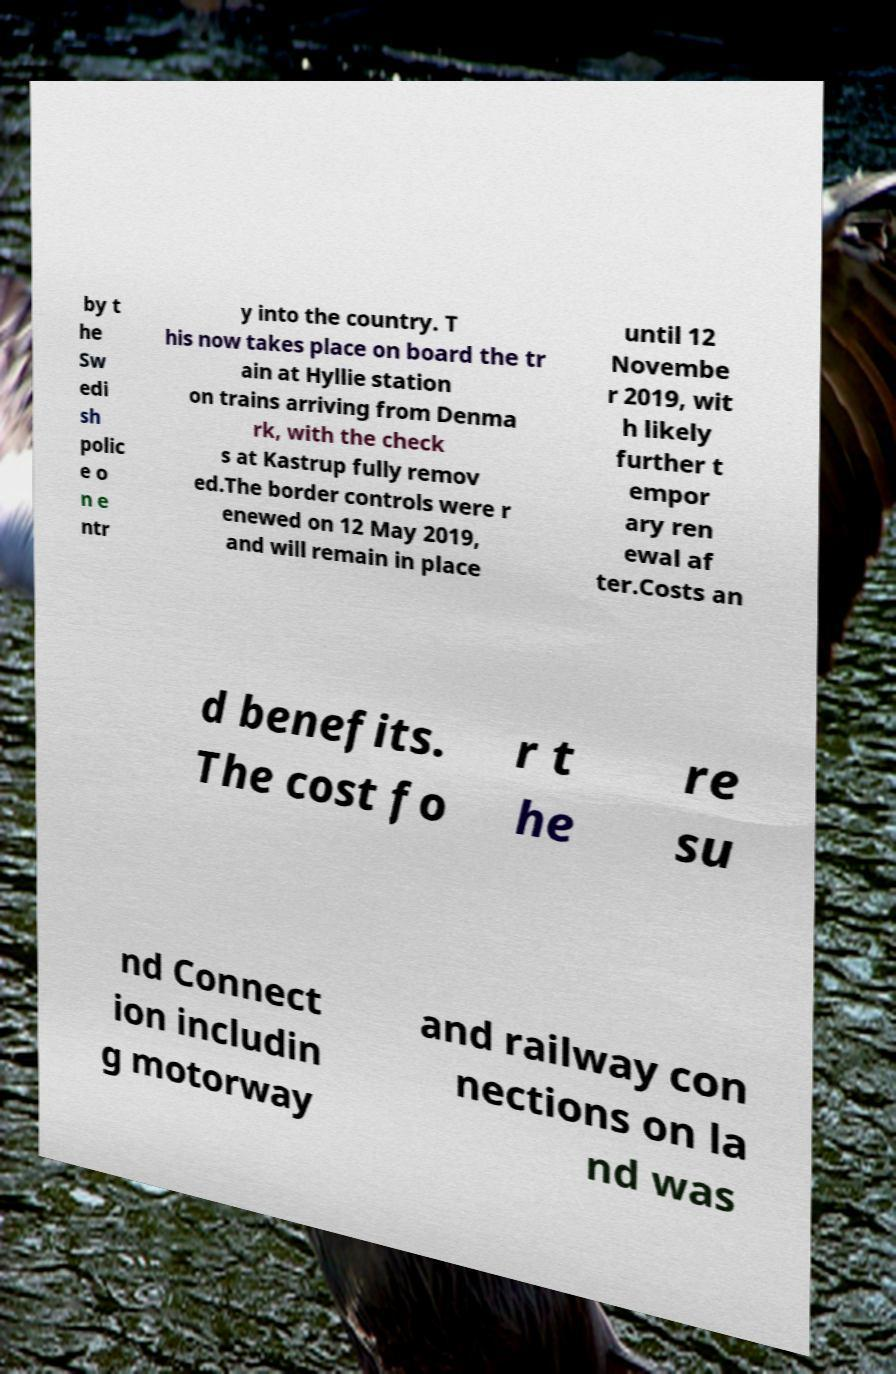What messages or text are displayed in this image? I need them in a readable, typed format. by t he Sw edi sh polic e o n e ntr y into the country. T his now takes place on board the tr ain at Hyllie station on trains arriving from Denma rk, with the check s at Kastrup fully remov ed.The border controls were r enewed on 12 May 2019, and will remain in place until 12 Novembe r 2019, wit h likely further t empor ary ren ewal af ter.Costs an d benefits. The cost fo r t he re su nd Connect ion includin g motorway and railway con nections on la nd was 